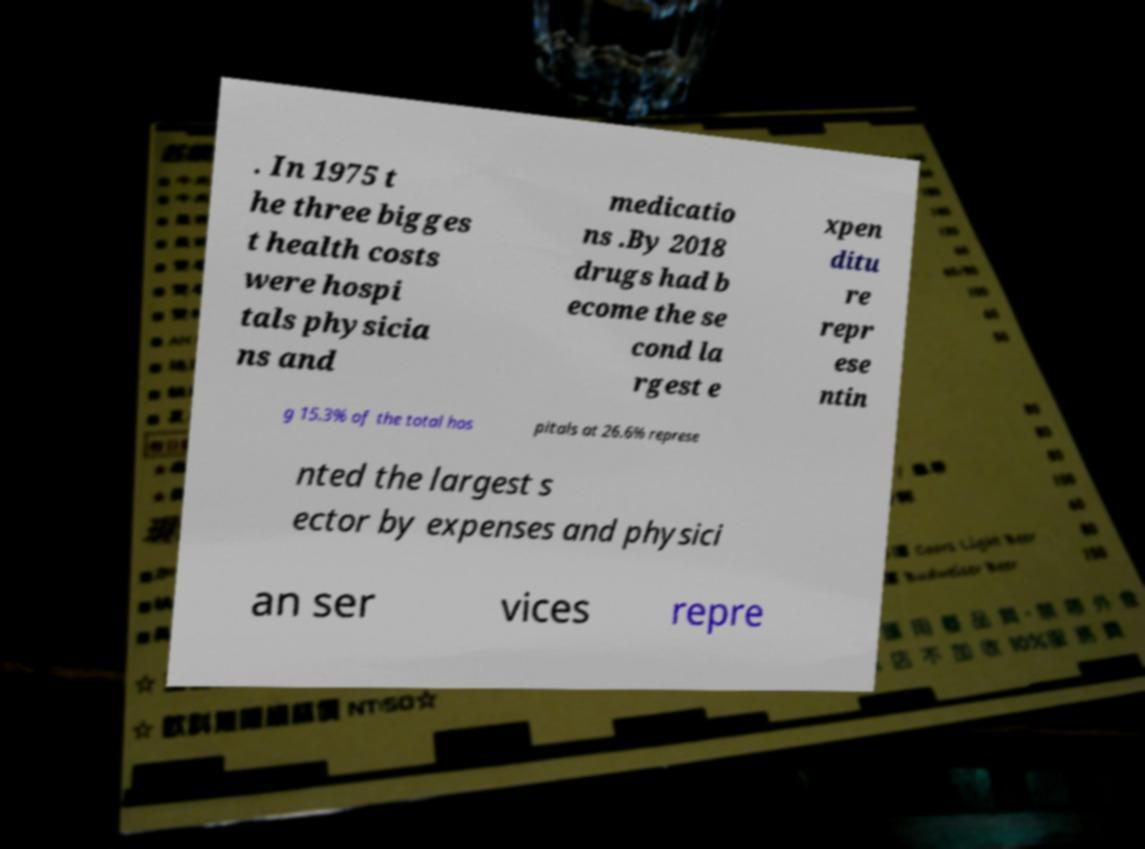I need the written content from this picture converted into text. Can you do that? . In 1975 t he three bigges t health costs were hospi tals physicia ns and medicatio ns .By 2018 drugs had b ecome the se cond la rgest e xpen ditu re repr ese ntin g 15.3% of the total hos pitals at 26.6% represe nted the largest s ector by expenses and physici an ser vices repre 